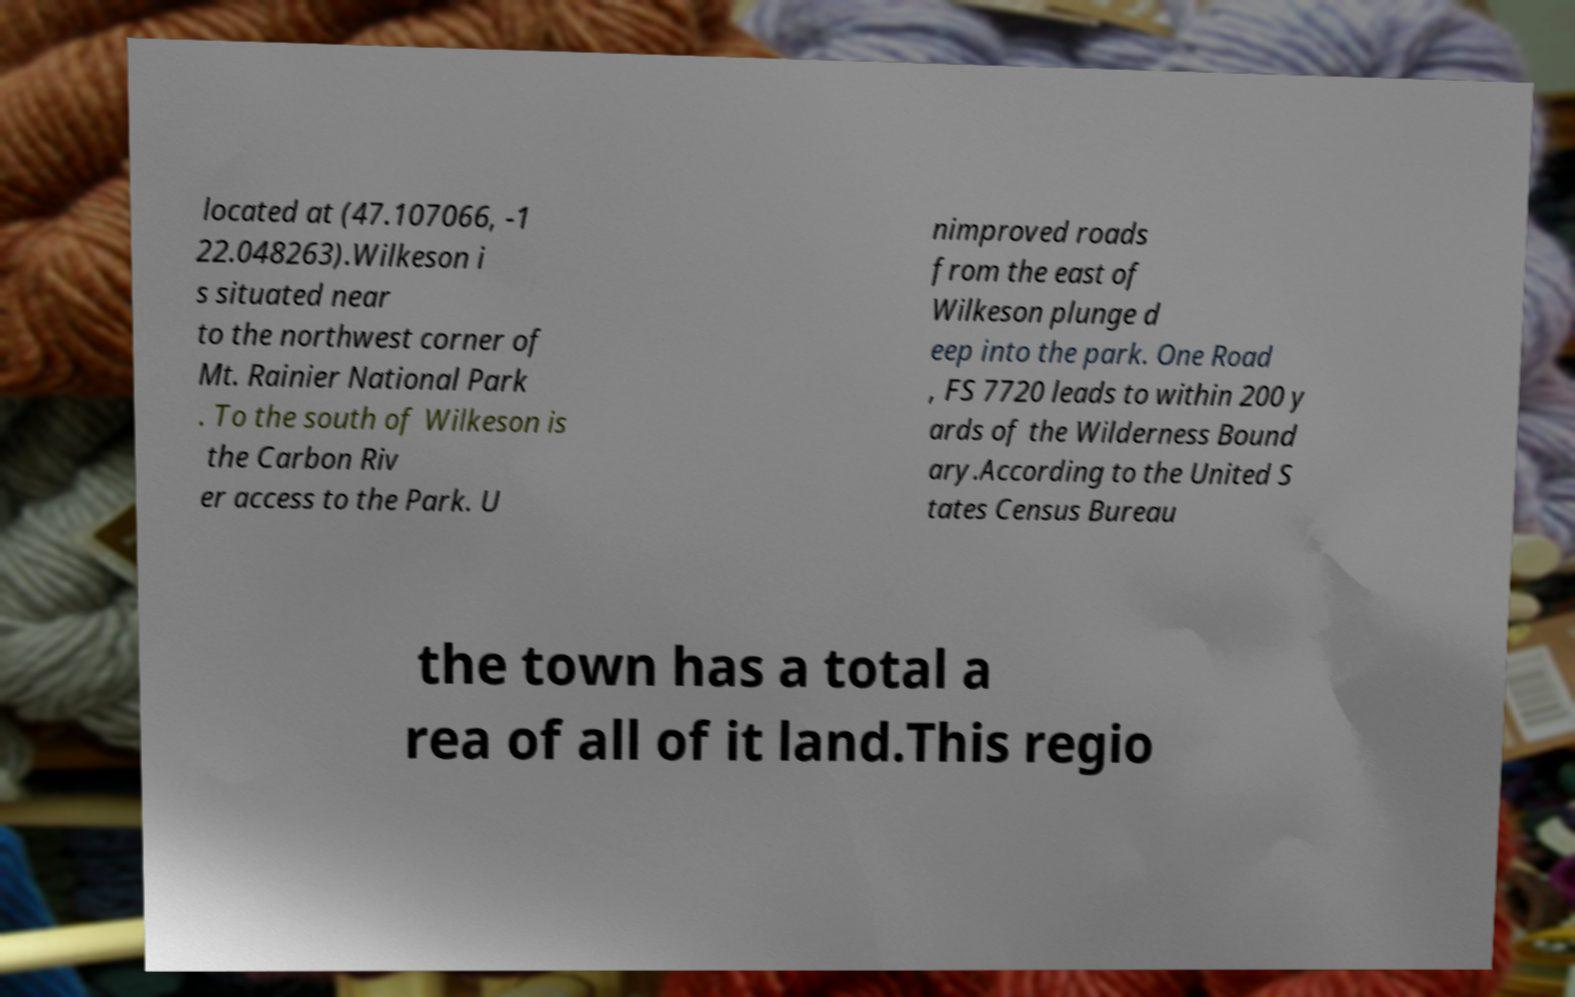What messages or text are displayed in this image? I need them in a readable, typed format. located at (47.107066, -1 22.048263).Wilkeson i s situated near to the northwest corner of Mt. Rainier National Park . To the south of Wilkeson is the Carbon Riv er access to the Park. U nimproved roads from the east of Wilkeson plunge d eep into the park. One Road , FS 7720 leads to within 200 y ards of the Wilderness Bound ary.According to the United S tates Census Bureau the town has a total a rea of all of it land.This regio 